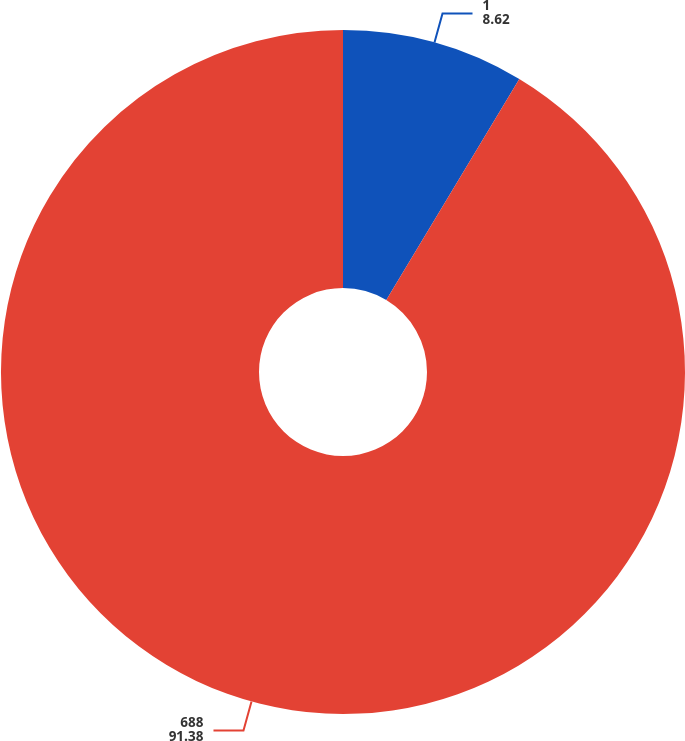Convert chart to OTSL. <chart><loc_0><loc_0><loc_500><loc_500><pie_chart><fcel>1<fcel>688<nl><fcel>8.62%<fcel>91.38%<nl></chart> 